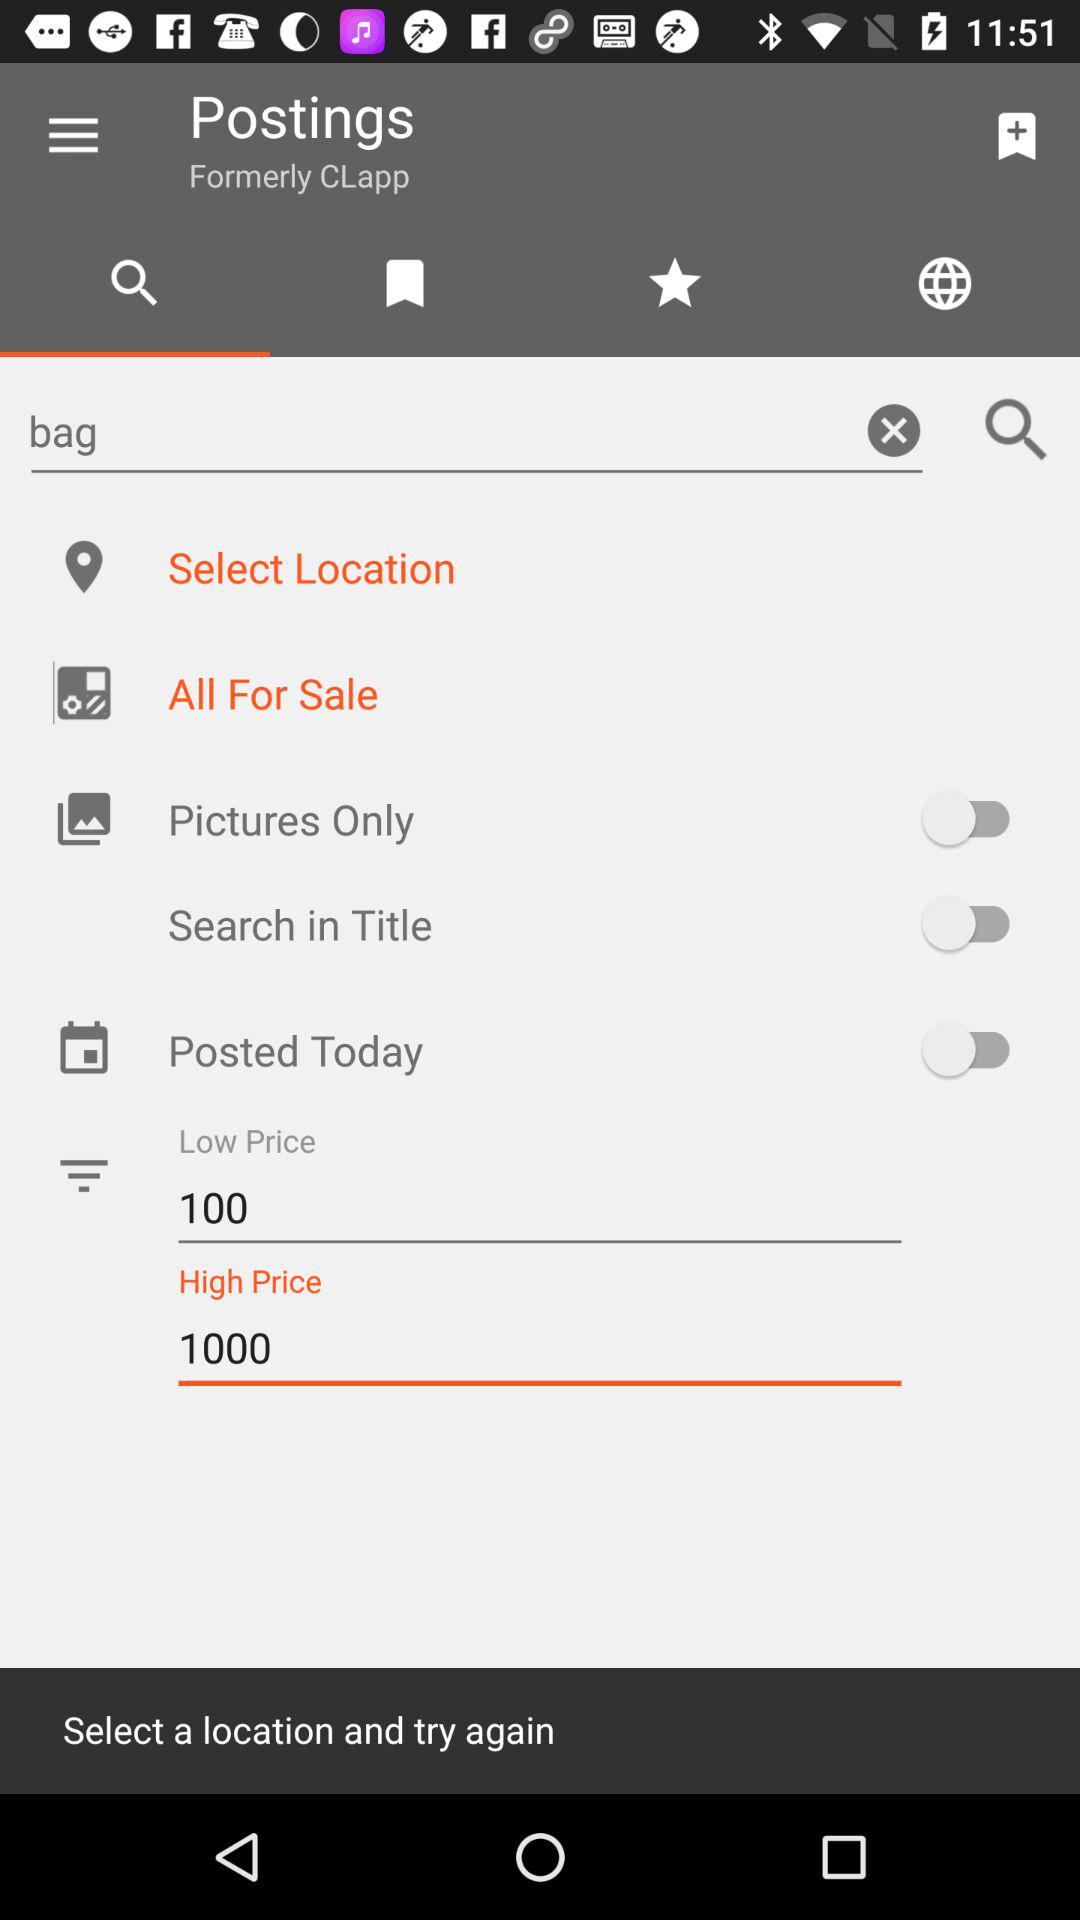How much more does the high price text input allow than the low price text input?
Answer the question using a single word or phrase. 900 